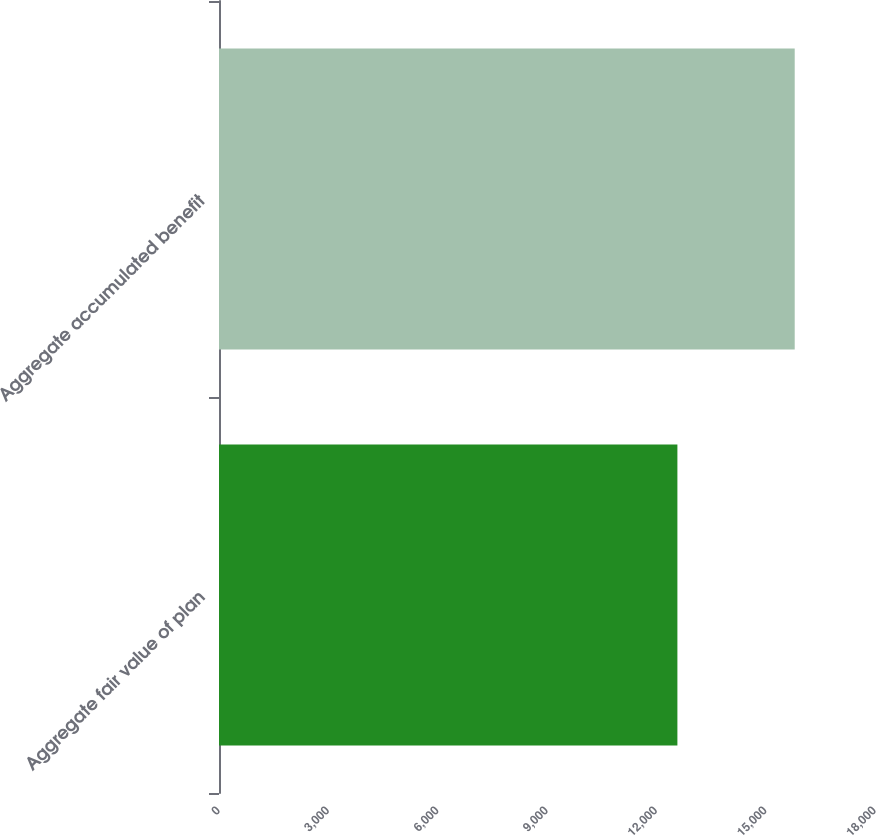<chart> <loc_0><loc_0><loc_500><loc_500><bar_chart><fcel>Aggregate fair value of plan<fcel>Aggregate accumulated benefit<nl><fcel>12578<fcel>15797<nl></chart> 